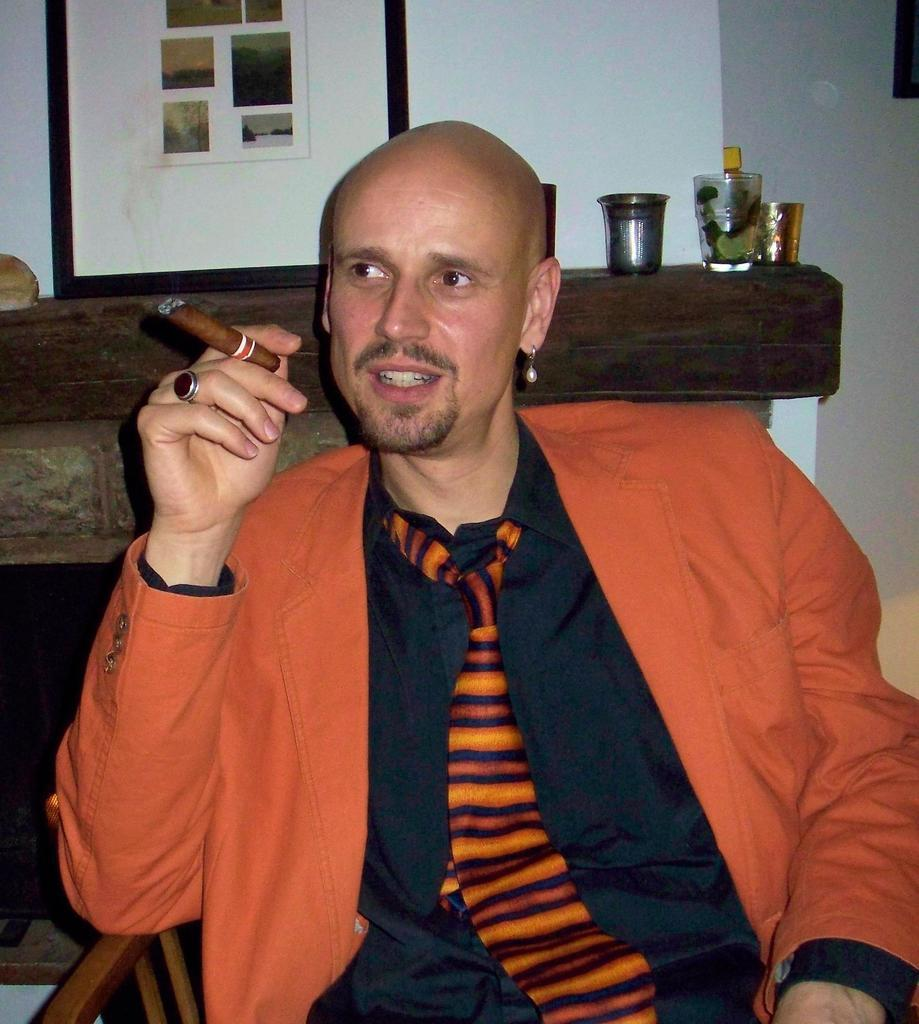What is the main subject of the image? There is a person in the image. What is the person holding in the image? The person is holding a cigar. Can you describe the frame in the image? There is a frame in the image, but its details are not specified. What else can be seen in the image besides the person and the frame? There are other unspecified things visible in the image. What type of judge is depicted in the image? There is no judge present in the image; it features a person holding a cigar. How many tanks are visible in the image? There are no tanks visible in the image. 